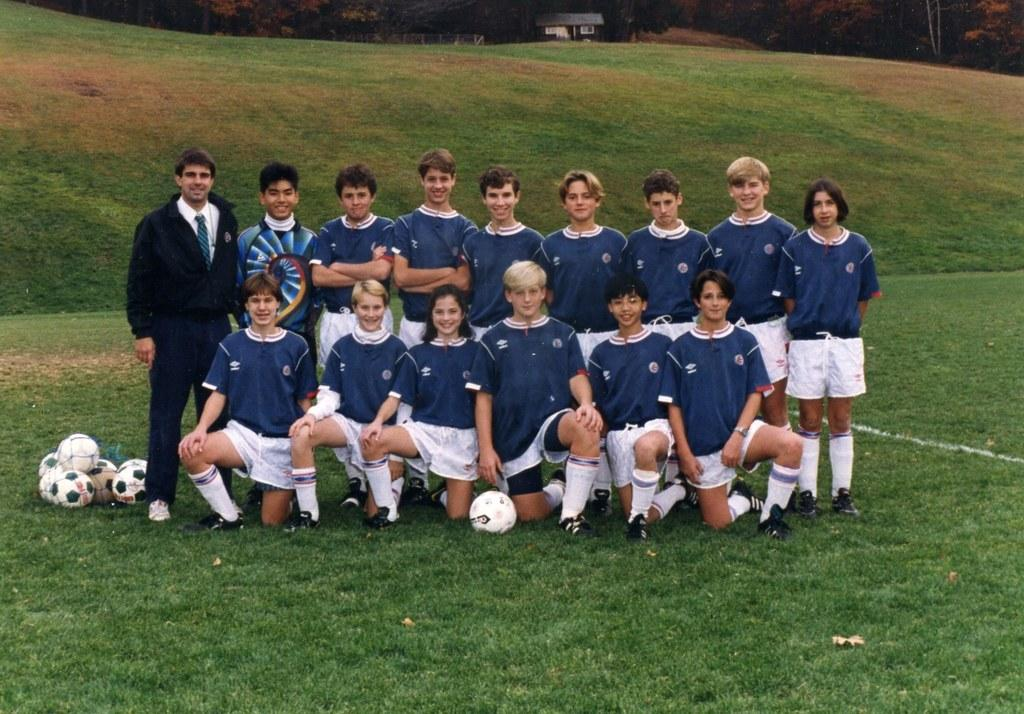How many persons are visible in the image? There are persons in the image. What objects are also present in the image? There are balls in the image. What type of surface is on the ground in the image? There is grass on the ground in the image. What is the name of the daughter of the person in the image? There is no information about a daughter or any personal details of the persons in the image. What type of mineral is visible in the image? There is no mineral, such as quartz, present in the image. 